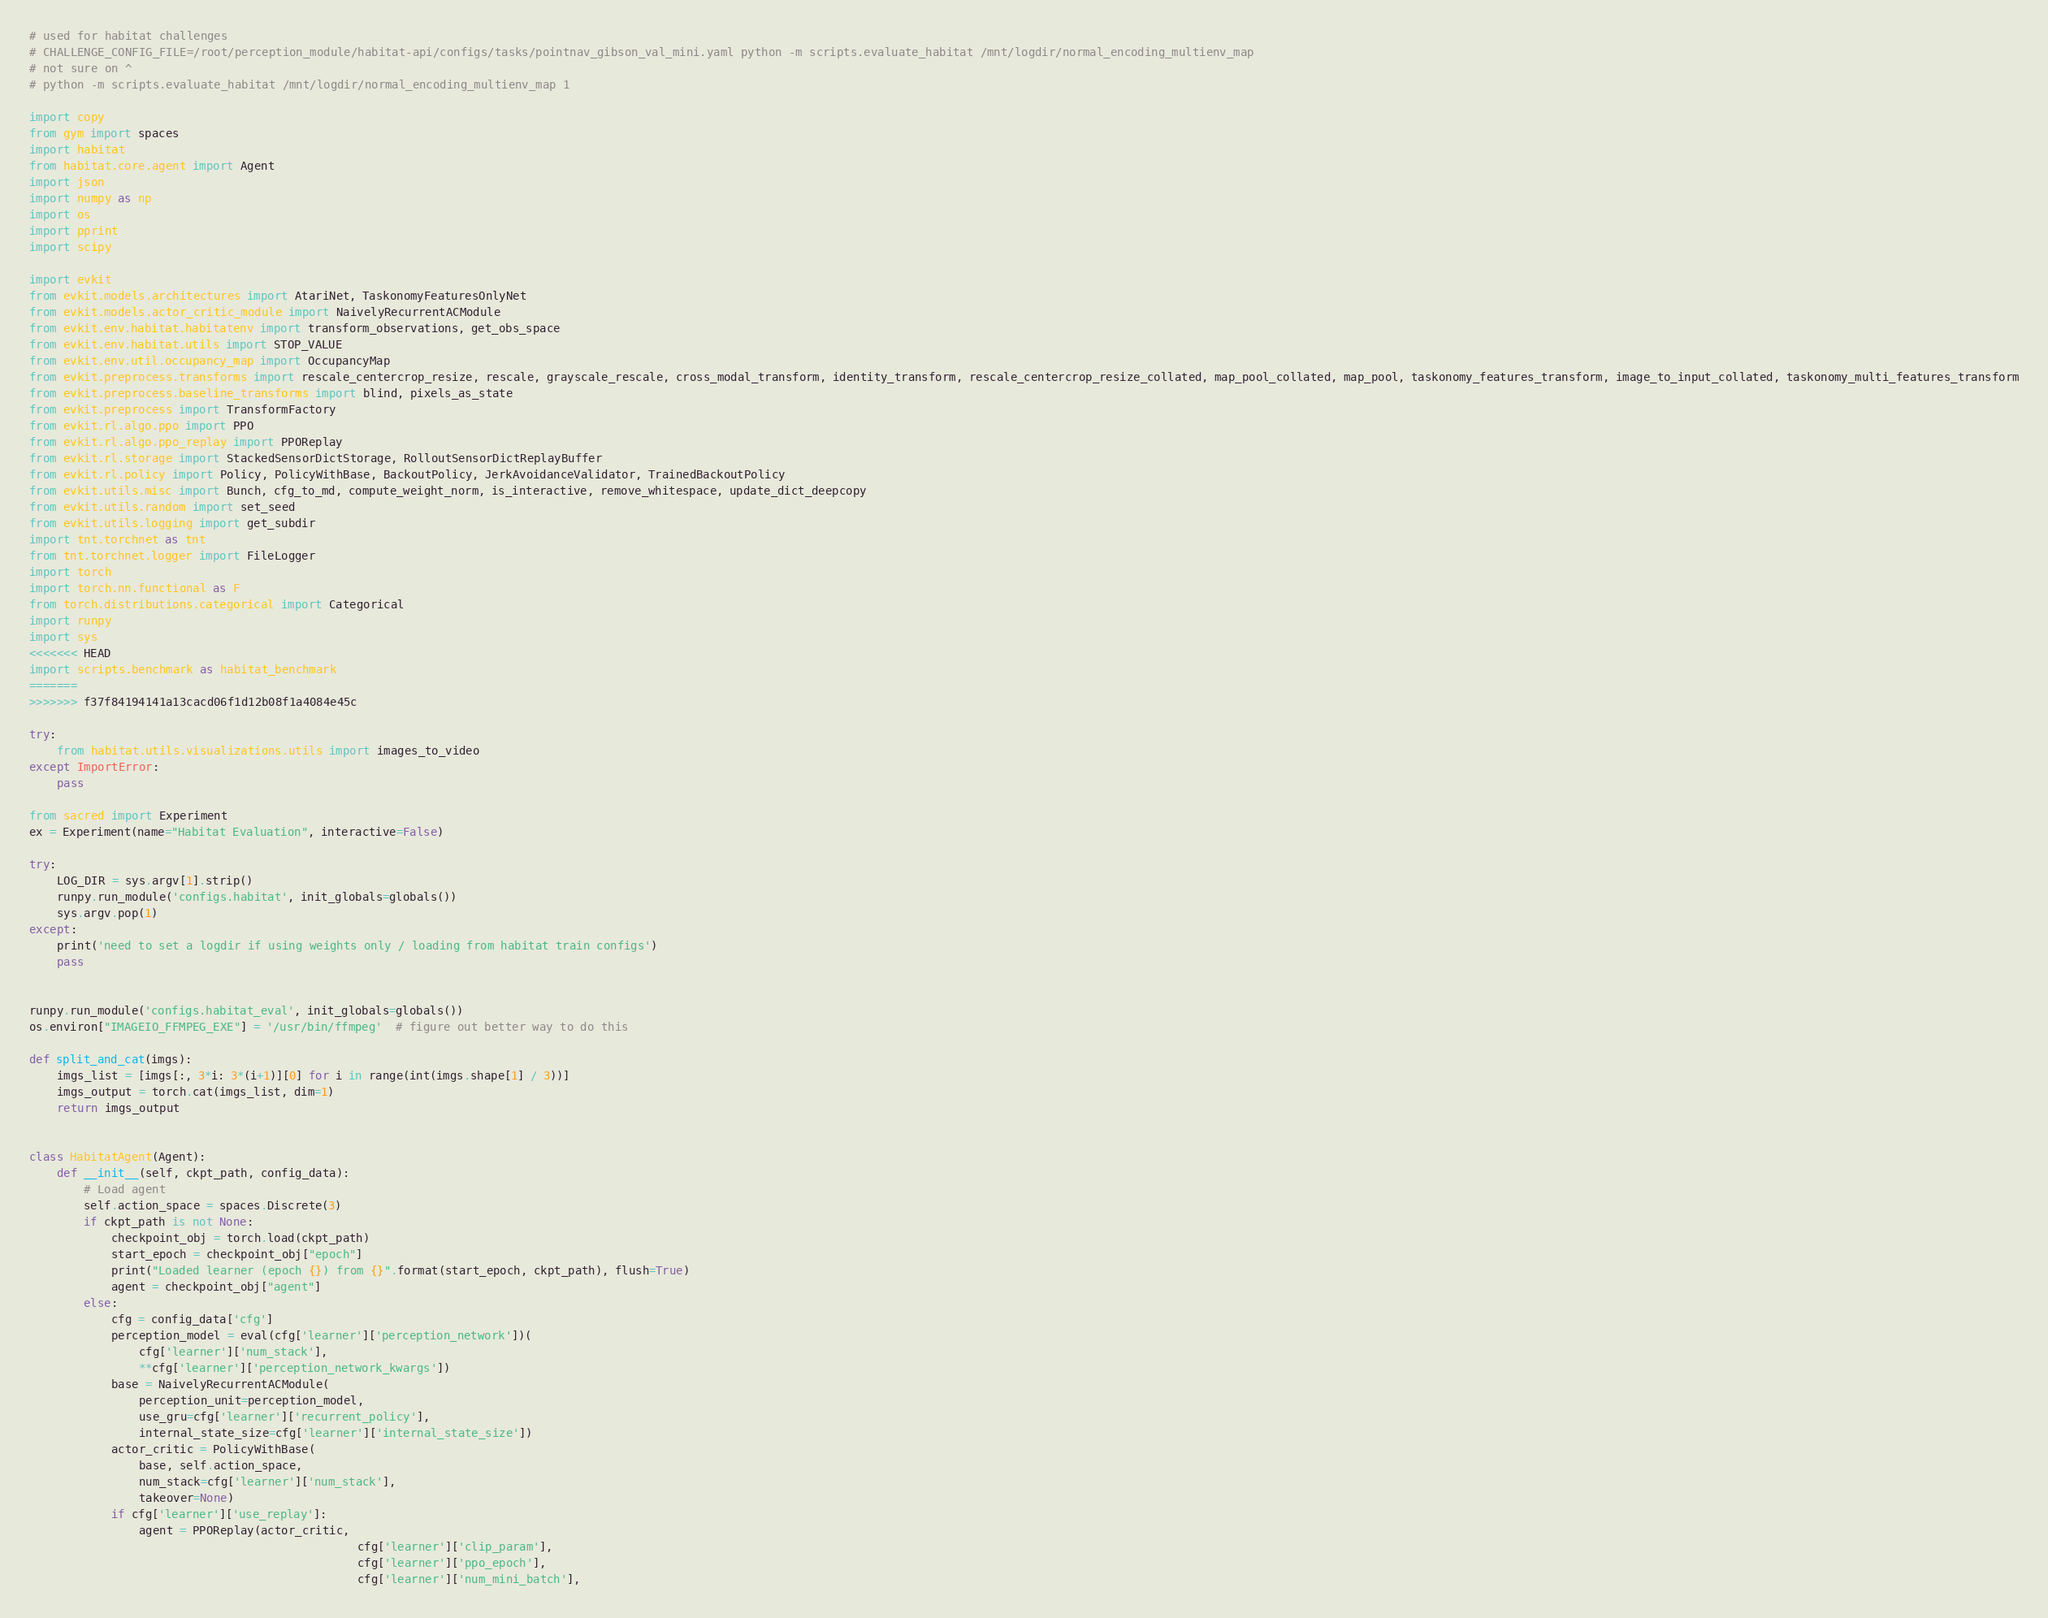<code> <loc_0><loc_0><loc_500><loc_500><_Python_># used for habitat challenges
# CHALLENGE_CONFIG_FILE=/root/perception_module/habitat-api/configs/tasks/pointnav_gibson_val_mini.yaml python -m scripts.evaluate_habitat /mnt/logdir/normal_encoding_multienv_map
# not sure on ^
# python -m scripts.evaluate_habitat /mnt/logdir/normal_encoding_multienv_map 1

import copy
from gym import spaces
import habitat
from habitat.core.agent import Agent
import json
import numpy as np
import os
import pprint
import scipy

import evkit
from evkit.models.architectures import AtariNet, TaskonomyFeaturesOnlyNet
from evkit.models.actor_critic_module import NaivelyRecurrentACModule
from evkit.env.habitat.habitatenv import transform_observations, get_obs_space
from evkit.env.habitat.utils import STOP_VALUE
from evkit.env.util.occupancy_map import OccupancyMap
from evkit.preprocess.transforms import rescale_centercrop_resize, rescale, grayscale_rescale, cross_modal_transform, identity_transform, rescale_centercrop_resize_collated, map_pool_collated, map_pool, taskonomy_features_transform, image_to_input_collated, taskonomy_multi_features_transform
from evkit.preprocess.baseline_transforms import blind, pixels_as_state
from evkit.preprocess import TransformFactory
from evkit.rl.algo.ppo import PPO
from evkit.rl.algo.ppo_replay import PPOReplay
from evkit.rl.storage import StackedSensorDictStorage, RolloutSensorDictReplayBuffer
from evkit.rl.policy import Policy, PolicyWithBase, BackoutPolicy, JerkAvoidanceValidator, TrainedBackoutPolicy
from evkit.utils.misc import Bunch, cfg_to_md, compute_weight_norm, is_interactive, remove_whitespace, update_dict_deepcopy
from evkit.utils.random import set_seed
from evkit.utils.logging import get_subdir
import tnt.torchnet as tnt
from tnt.torchnet.logger import FileLogger
import torch
import torch.nn.functional as F
from torch.distributions.categorical import Categorical
import runpy
import sys
<<<<<<< HEAD
import scripts.benchmark as habitat_benchmark
=======
>>>>>>> f37f84194141a13cacd06f1d12b08f1a4084e45c

try:
    from habitat.utils.visualizations.utils import images_to_video
except ImportError:
    pass

from sacred import Experiment
ex = Experiment(name="Habitat Evaluation", interactive=False)

try:
    LOG_DIR = sys.argv[1].strip()
    runpy.run_module('configs.habitat', init_globals=globals())
    sys.argv.pop(1)
except:
    print('need to set a logdir if using weights only / loading from habitat train configs')
    pass


runpy.run_module('configs.habitat_eval', init_globals=globals())
os.environ["IMAGEIO_FFMPEG_EXE"] = '/usr/bin/ffmpeg'  # figure out better way to do this

def split_and_cat(imgs):
    imgs_list = [imgs[:, 3*i: 3*(i+1)][0] for i in range(int(imgs.shape[1] / 3))]
    imgs_output = torch.cat(imgs_list, dim=1)
    return imgs_output


class HabitatAgent(Agent):
    def __init__(self, ckpt_path, config_data):
        # Load agent
        self.action_space = spaces.Discrete(3)
        if ckpt_path is not None:
            checkpoint_obj = torch.load(ckpt_path)
            start_epoch = checkpoint_obj["epoch"]
            print("Loaded learner (epoch {}) from {}".format(start_epoch, ckpt_path), flush=True)
            agent = checkpoint_obj["agent"]
        else:
            cfg = config_data['cfg']
            perception_model = eval(cfg['learner']['perception_network'])(
                cfg['learner']['num_stack'],
                **cfg['learner']['perception_network_kwargs'])
            base = NaivelyRecurrentACModule(
                perception_unit=perception_model,
                use_gru=cfg['learner']['recurrent_policy'],
                internal_state_size=cfg['learner']['internal_state_size'])
            actor_critic = PolicyWithBase(
                base, self.action_space,
                num_stack=cfg['learner']['num_stack'],
                takeover=None)
            if cfg['learner']['use_replay']:
                agent = PPOReplay(actor_critic,
                                                cfg['learner']['clip_param'],
                                                cfg['learner']['ppo_epoch'],
                                                cfg['learner']['num_mini_batch'],</code> 